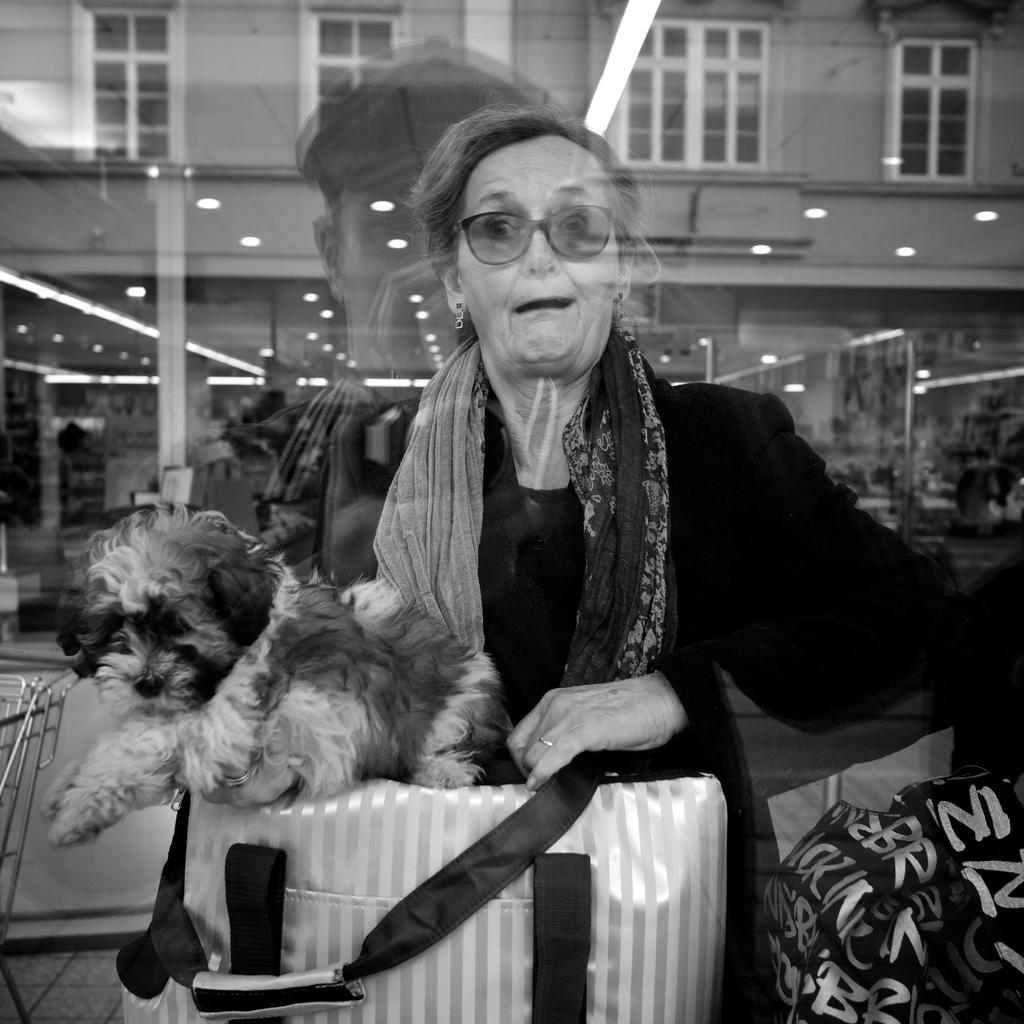Who is the main subject in the image? There is a lady in the image. What is the lady wearing? The lady is wearing a black dress, a scarf, and spectacles. What is the lady holding in the image? The lady is holding a bag and a puppy. What can be seen in the background of the image? There is a building with windows in the background of the image. How many apples are on the cart in the image? There is no cart or apples present in the image. What type of earth can be seen in the image? The image does not depict any earth or soil; it features a lady holding a puppy and a bag. 